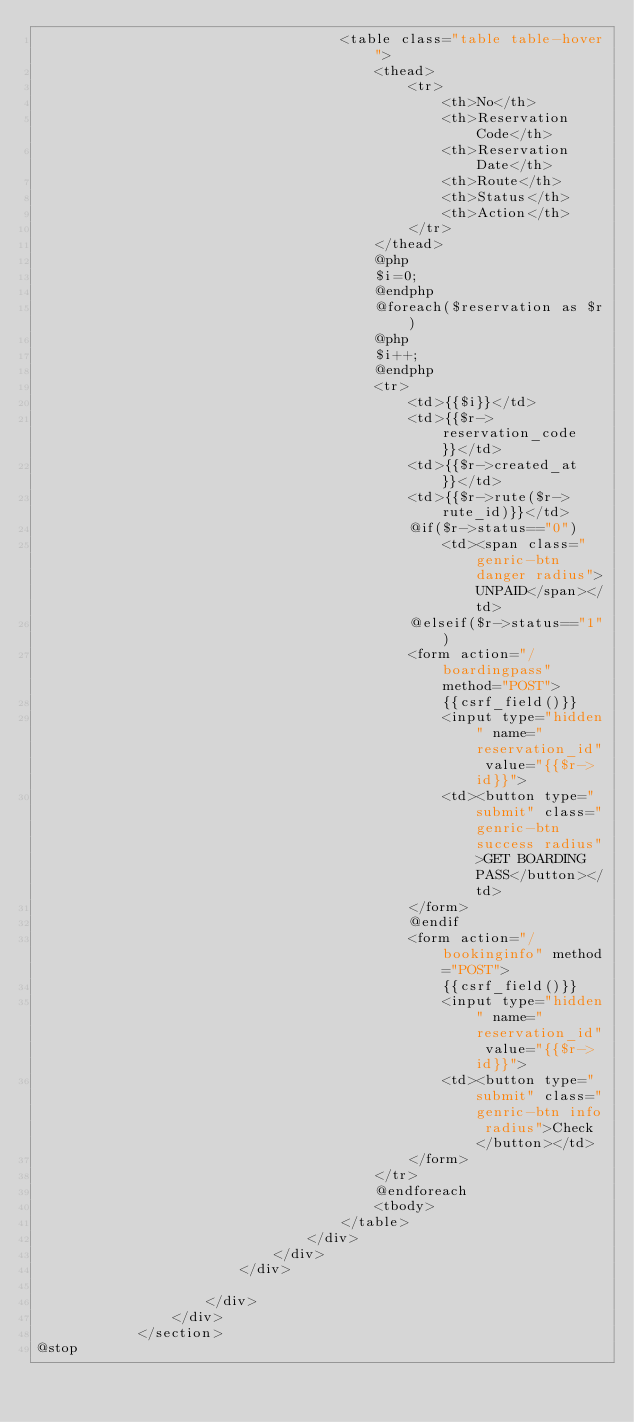Convert code to text. <code><loc_0><loc_0><loc_500><loc_500><_PHP_>									<table class="table table-hover">
										<thead>
											<tr>
												<th>No</th>
												<th>Reservation Code</th>
												<th>Reservation Date</th>
												<th>Route</th>
												<th>Status</th>
												<th>Action</th>
											</tr>
										</thead>
										@php
										$i=0;
										@endphp
										@foreach($reservation as $r)
										@php
										$i++;
										@endphp
										<tr>
											<td>{{$i}}</td>
											<td>{{$r->reservation_code}}</td>
											<td>{{$r->created_at}}</td>
											<td>{{$r->rute($r->rute_id)}}</td>
											@if($r->status=="0")
												<td><span class="genric-btn danger radius">UNPAID</span></td>
											@elseif($r->status=="1")
											<form action="/boardingpass" method="POST">
												{{csrf_field()}}
												<input type="hidden" name="reservation_id" value="{{$r->id}}">
												<td><button type="submit" class="genric-btn success radius">GET BOARDING PASS</button></td>
											</form>
											@endif
											<form action="/bookinginfo" method="POST">
												{{csrf_field()}}
												<input type="hidden" name="reservation_id" value="{{$r->id}}">
												<td><button type="submit" class="genric-btn info radius">Check</button></td>
											</form>
										</tr>
										@endforeach
										<tbody>	
									</table>
								</div>
							</div>
						</div>	
						
					</div>
				</div>	
			</section>
@stop</code> 